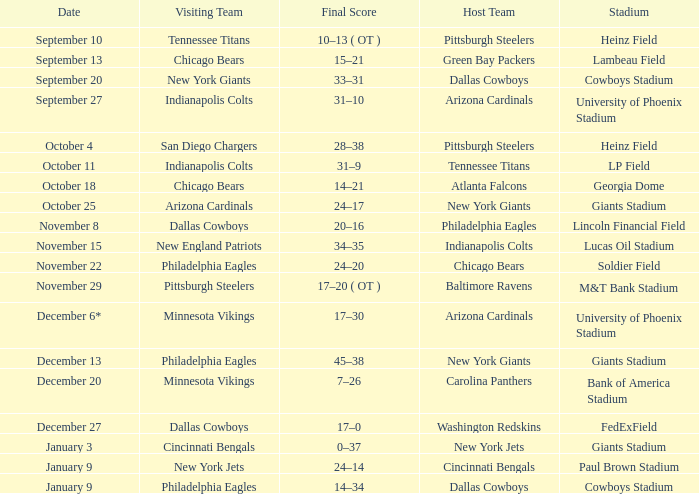Tell me the final score for january 9 for cincinnati bengals 24–14. 